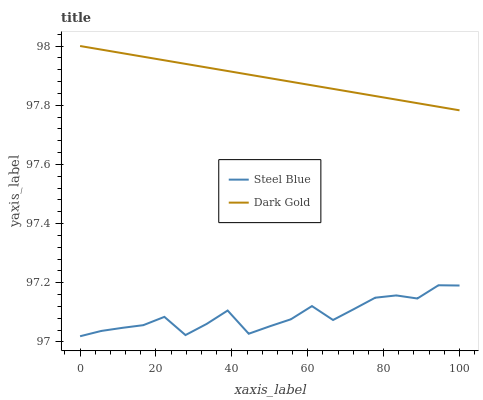Does Steel Blue have the minimum area under the curve?
Answer yes or no. Yes. Does Dark Gold have the maximum area under the curve?
Answer yes or no. Yes. Does Dark Gold have the minimum area under the curve?
Answer yes or no. No. Is Dark Gold the smoothest?
Answer yes or no. Yes. Is Steel Blue the roughest?
Answer yes or no. Yes. Is Dark Gold the roughest?
Answer yes or no. No. Does Dark Gold have the lowest value?
Answer yes or no. No. Does Dark Gold have the highest value?
Answer yes or no. Yes. Is Steel Blue less than Dark Gold?
Answer yes or no. Yes. Is Dark Gold greater than Steel Blue?
Answer yes or no. Yes. Does Steel Blue intersect Dark Gold?
Answer yes or no. No. 